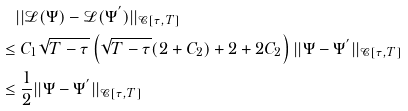Convert formula to latex. <formula><loc_0><loc_0><loc_500><loc_500>& | | \mathcal { L } ( \Psi ) - \mathcal { L } ( \Psi ^ { ^ { \prime } } ) | | _ { \mathcal { C } [ \tau , T ] } \\ \leq & \ C _ { 1 } \sqrt { T - \tau } \left ( \sqrt { T - \tau } ( 2 + C _ { 2 } ) + 2 + 2 C _ { 2 } \right ) | | \Psi - \Psi ^ { ^ { \prime } } | | _ { \mathcal { C } [ \tau , T ] } \\ \leq & \ \frac { 1 } { 2 } | | \Psi - \Psi ^ { ^ { \prime } } | | _ { \mathcal { C } [ \tau , T ] }</formula> 